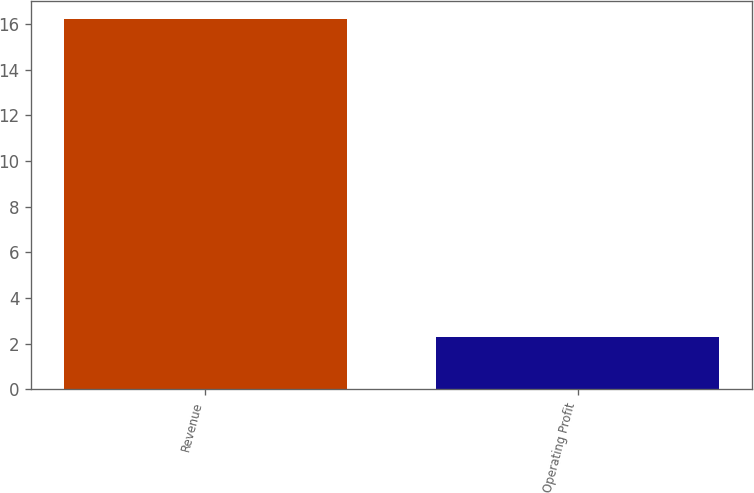Convert chart to OTSL. <chart><loc_0><loc_0><loc_500><loc_500><bar_chart><fcel>Revenue<fcel>Operating Profit<nl><fcel>16.2<fcel>2.3<nl></chart> 